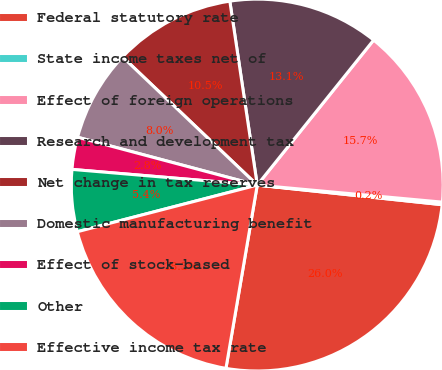Convert chart to OTSL. <chart><loc_0><loc_0><loc_500><loc_500><pie_chart><fcel>Federal statutory rate<fcel>State income taxes net of<fcel>Effect of foreign operations<fcel>Research and development tax<fcel>Net change in tax reserves<fcel>Domestic manufacturing benefit<fcel>Effect of stock-based<fcel>Other<fcel>Effective income tax rate<nl><fcel>26.01%<fcel>0.22%<fcel>15.7%<fcel>13.12%<fcel>10.54%<fcel>7.96%<fcel>2.8%<fcel>5.38%<fcel>18.27%<nl></chart> 